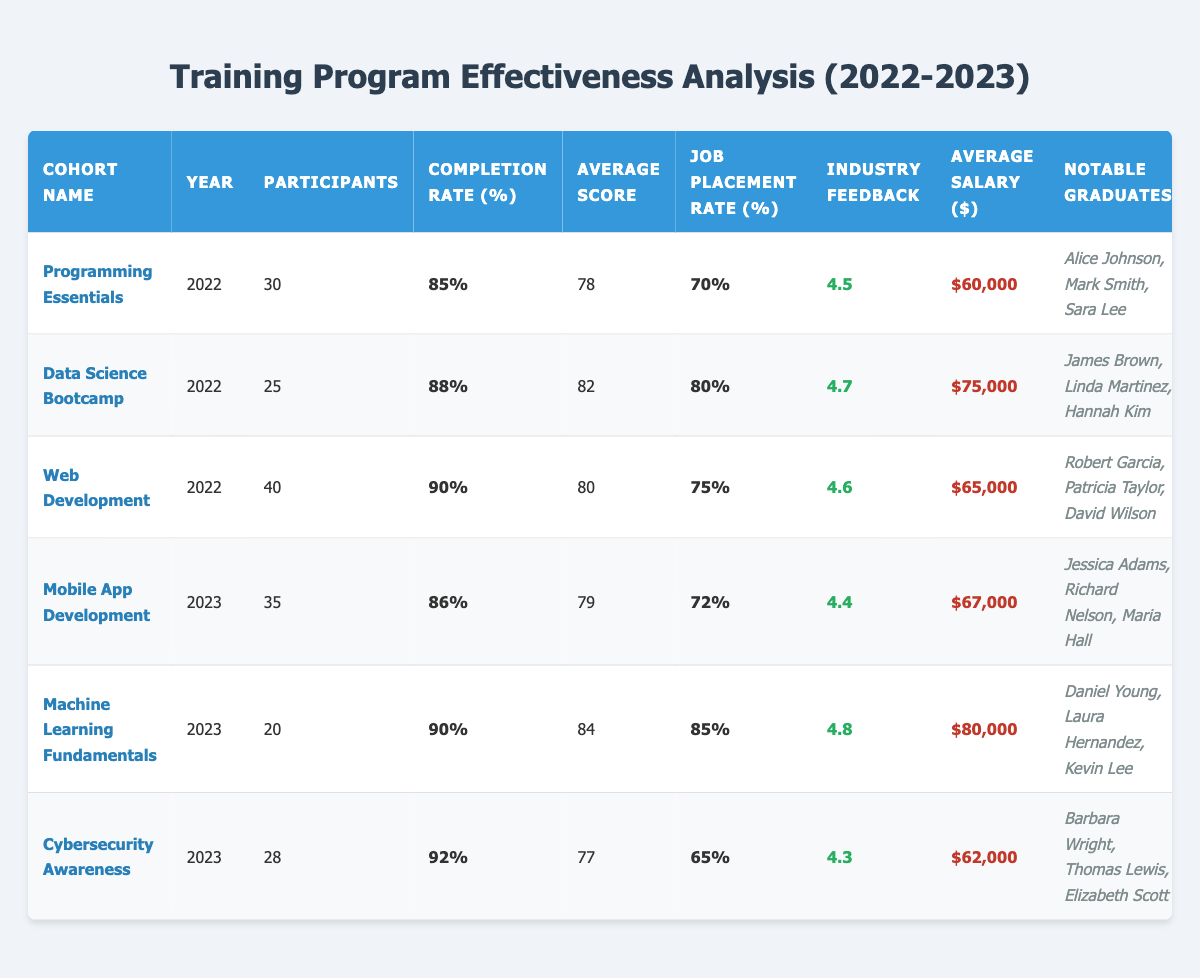What is the completion rate of the Data Science Bootcamp? The completion rate for the Data Science Bootcamp cohort in 2022 is listed as 88%.
Answer: 88% Which cohort had the highest job placement rate? Comparing the job placement rates, Machine Learning Fundamentals in 2023 had the highest job placement rate at 85%.
Answer: Machine Learning Fundamentals What is the average salary of participants in the Programming Essentials cohort? The average salary for the Programming Essentials cohort in 2022 is stated as $60,000.
Answer: $60,000 How many participants were there in the Web Development cohort? The number of participants in the Web Development cohort for 2022 is shown as 40.
Answer: 40 What is the difference in average scores between the Mobile App Development and Machine Learning Fundamentals cohorts? The Mobile App Development cohort has an average score of 79, while the Machine Learning Fundamentals cohort has 84. The difference is calculated as 84 - 79 = 5.
Answer: 5 Is the industry feedback for the Cybersecurity Awareness cohort lower than that of the Data Science Bootcamp? The industry feedback score for Cybersecurity Awareness is 4.3, while for Data Science Bootcamp it is 4.7. Since 4.3 is less than 4.7, the statement is true.
Answer: Yes What was the total number of participants across all cohorts in 2023? The participants in 2023 are Mobile App Development (35), Machine Learning Fundamentals (20), and Cybersecurity Awareness (28), summing up to 35 + 20 + 28 = 83 participants.
Answer: 83 Which cohort had the lowest average salary, and what was that salary? By comparing average salaries, Cybersecurity Awareness cohort had the lowest average salary at $62,000.
Answer: Cybersecurity Awareness, $62,000 Was the completion rate of the Web Development cohort closer to 90% or 85%? The completion rate for Web Development is 90%, which is more than 85%, making it closer to 90%.
Answer: 90% How many notable graduates are there from the Mobile App Development cohort? The notable graduates listed for the Mobile App Development cohort are three: Jessica Adams, Richard Nelson, and Maria Hall.
Answer: 3 